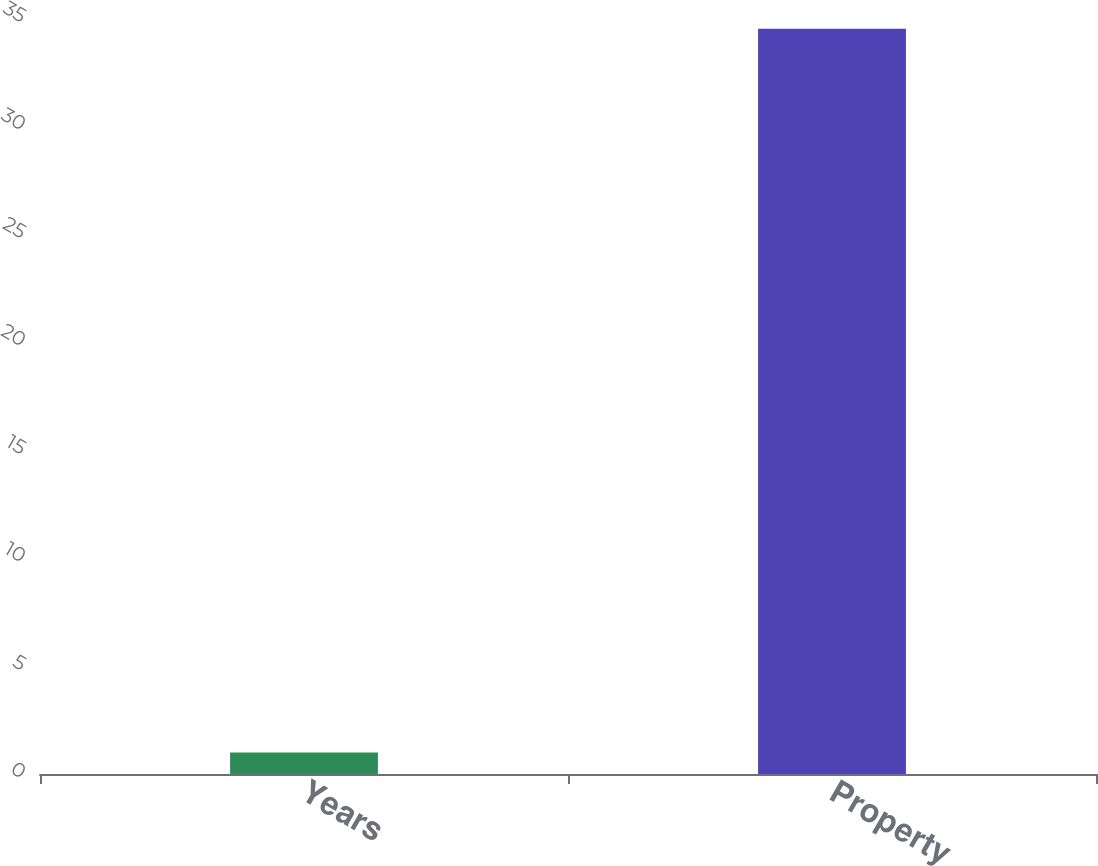Convert chart. <chart><loc_0><loc_0><loc_500><loc_500><bar_chart><fcel>Years<fcel>Property<nl><fcel>1<fcel>34.5<nl></chart> 